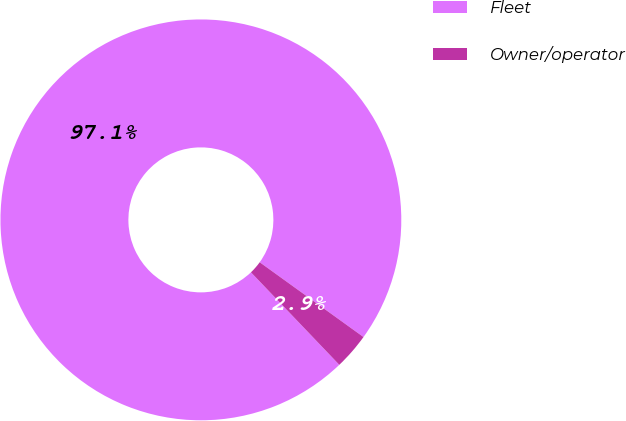Convert chart to OTSL. <chart><loc_0><loc_0><loc_500><loc_500><pie_chart><fcel>Fleet<fcel>Owner/operator<nl><fcel>97.07%<fcel>2.93%<nl></chart> 